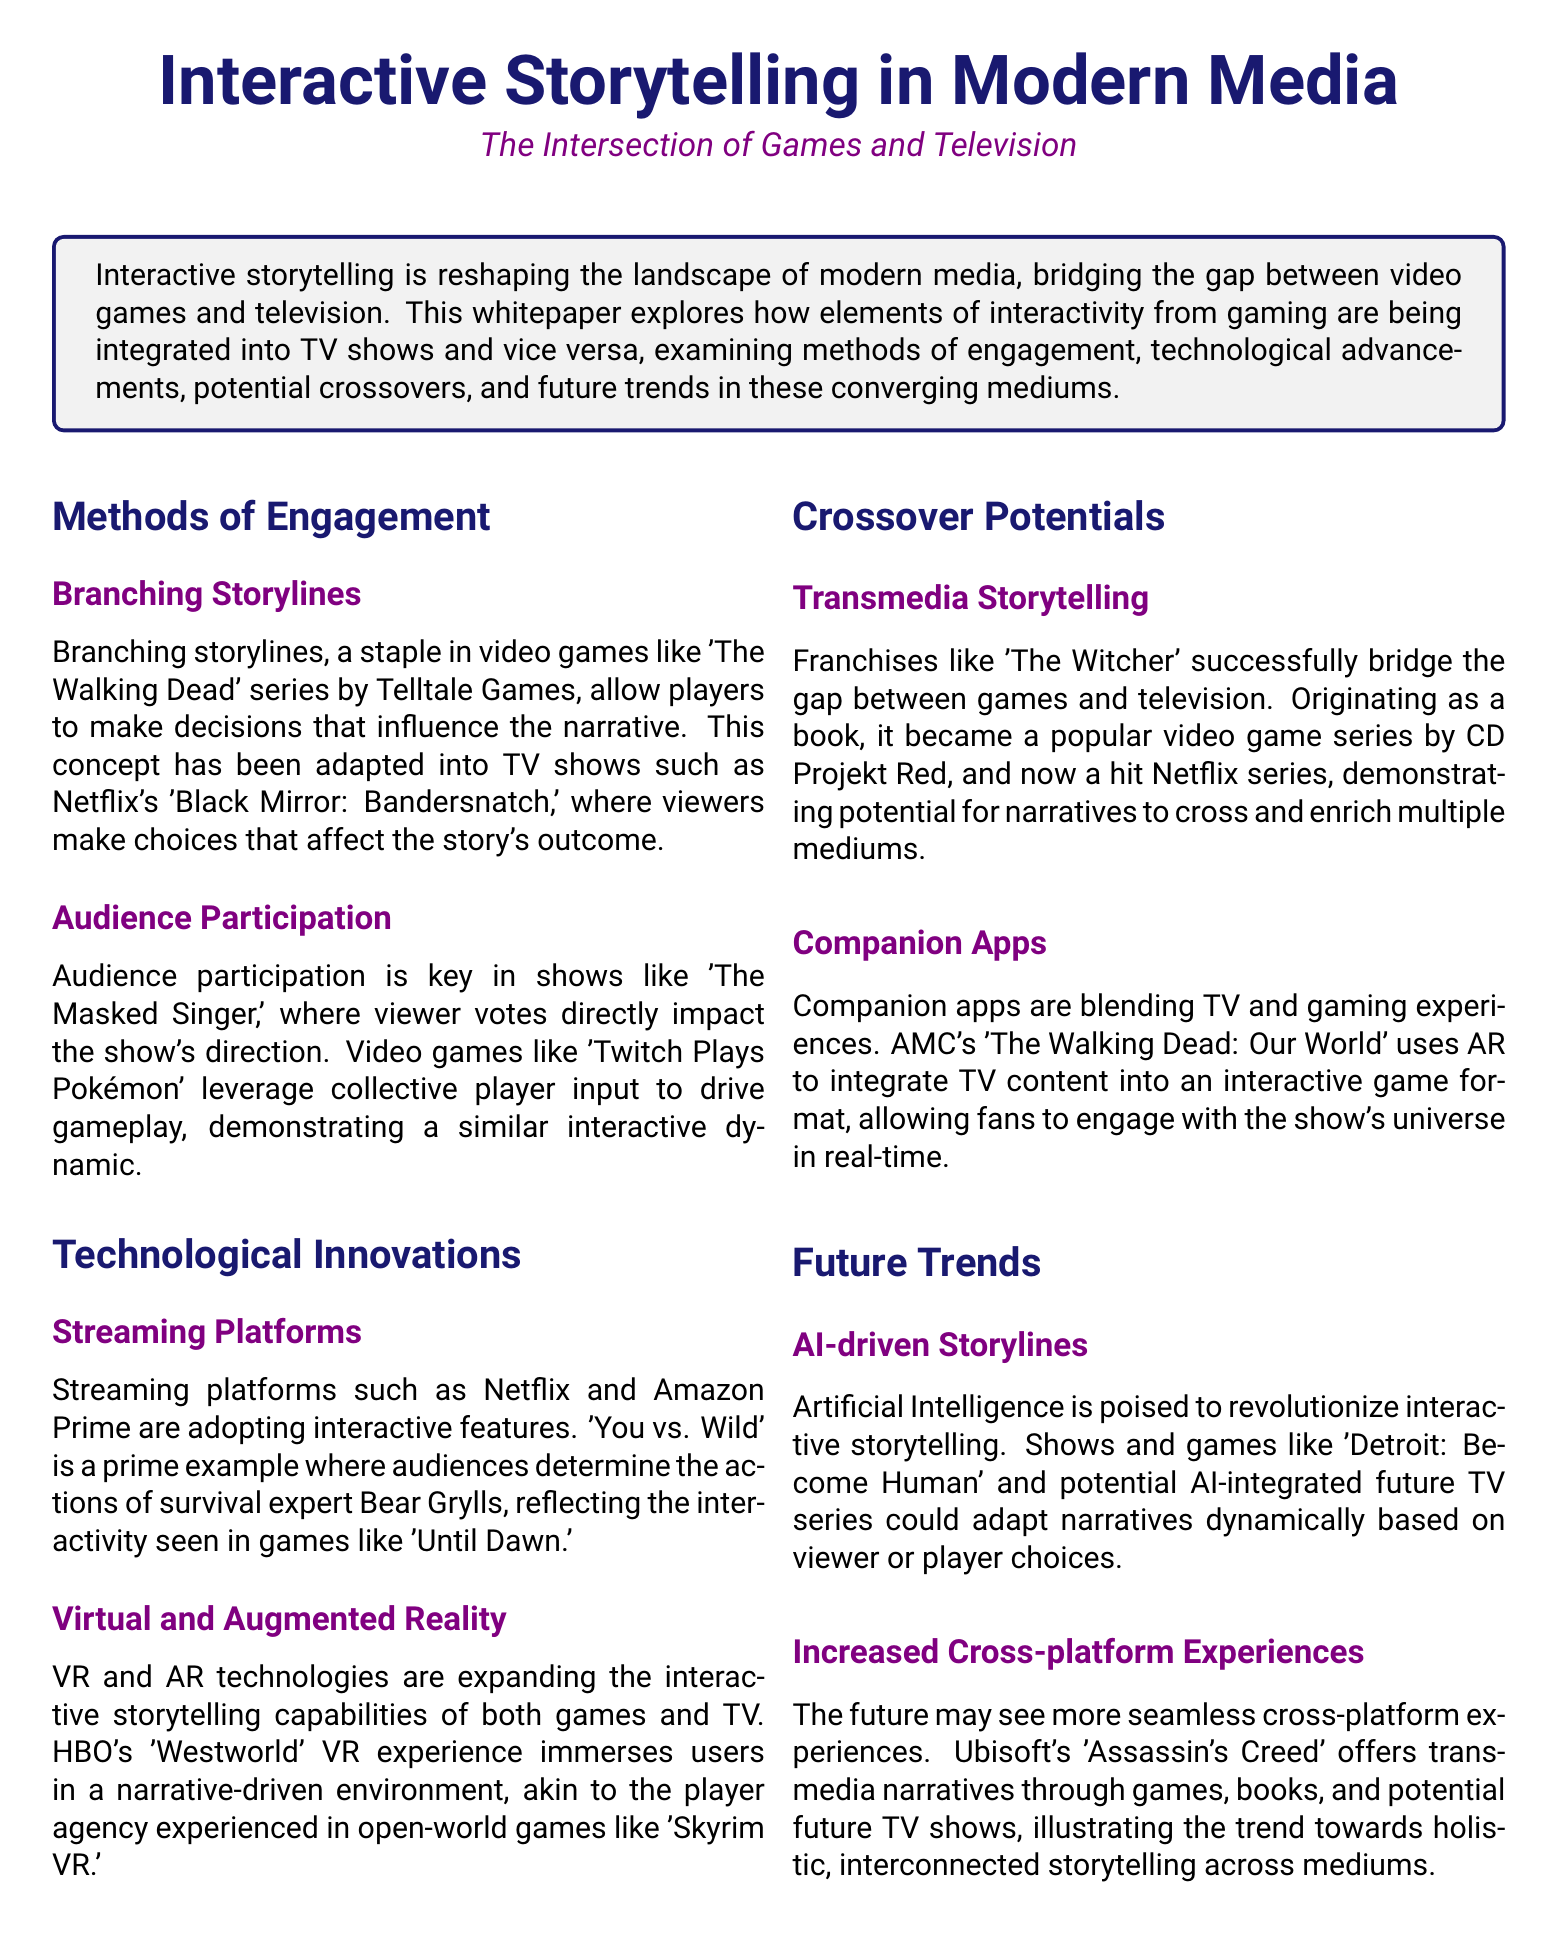What is the title of the whitepaper? The title of the whitepaper is stated at the beginning of the document.
Answer: Interactive Storytelling in Modern Media What example is given for audience participation in TV shows? The document mentions a specific TV show that exemplifies audience participation.
Answer: The Masked Singer Which technology is expanding interactive storytelling capabilities? The section on technological innovations discusses various technologies relevant to the topic.
Answer: Virtual and Augmented Reality What narrative technique allows player decisions to influence outcomes? The document elaborates on a specific storytelling method used in games and adapted in TV shows.
Answer: Branching Storylines Name one franchise that exemplifies transmedia storytelling. Transmedia storytelling is highlighted through a specific example in the document.
Answer: The Witcher What interactive feature is adopted by streaming platforms like Netflix? The document highlights a specific interactive feature used by streaming services.
Answer: Interactive features Which gaming experience reflects interactivity similar to 'You vs. Wild'? The document compares another game that showcases similar interactive mechanics.
Answer: Until Dawn What future trend involves adapting narratives based on choices? The document discusses a specific trend that harnesses technology for storytelling.
Answer: AI-driven Storylines What type of apps are blending TV and gaming experiences? The document notes a specific app category that integrates both mediums.
Answer: Companion Apps 